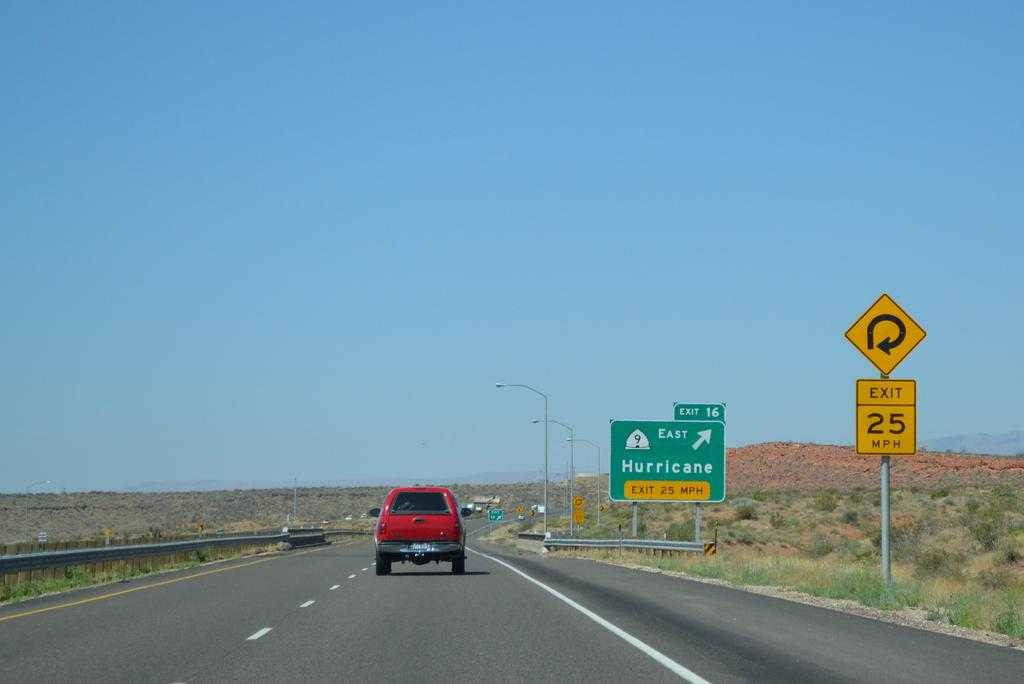<image>
Offer a succinct explanation of the picture presented. A red truck drives down the road on a sunny day, passing a sign for the Hurricane exit. 